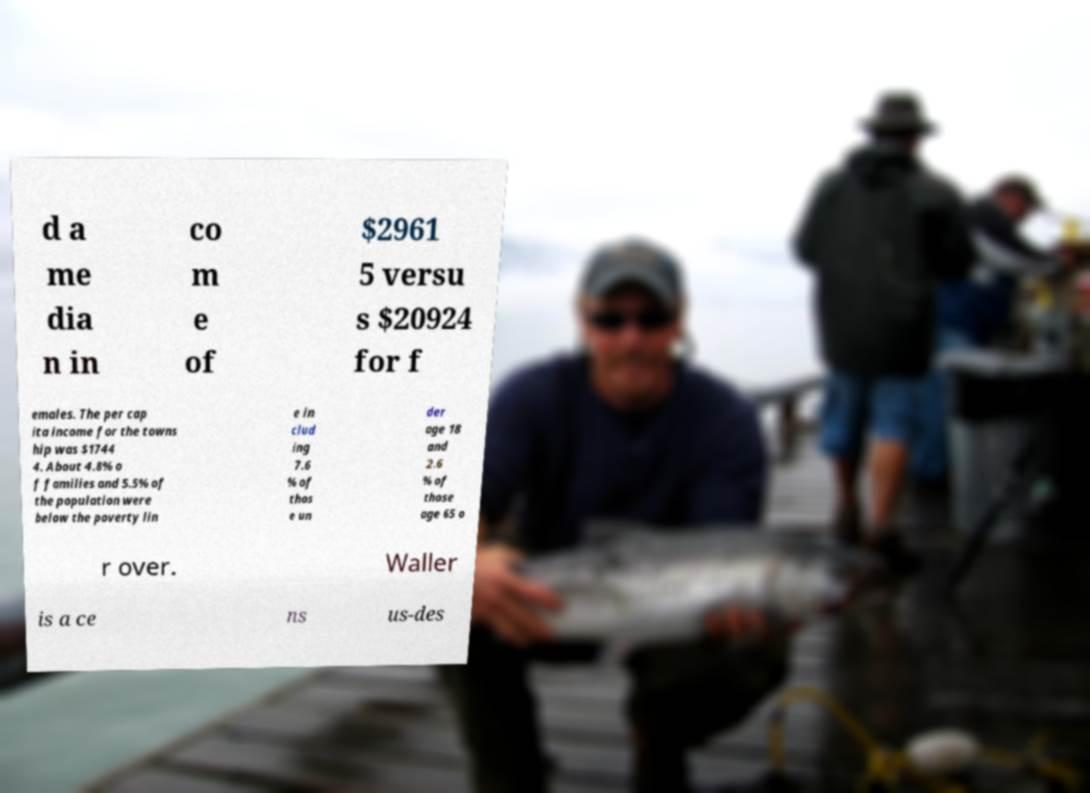Please identify and transcribe the text found in this image. d a me dia n in co m e of $2961 5 versu s $20924 for f emales. The per cap ita income for the towns hip was $1744 4. About 4.8% o f families and 5.5% of the population were below the poverty lin e in clud ing 7.6 % of thos e un der age 18 and 2.6 % of those age 65 o r over. Waller is a ce ns us-des 